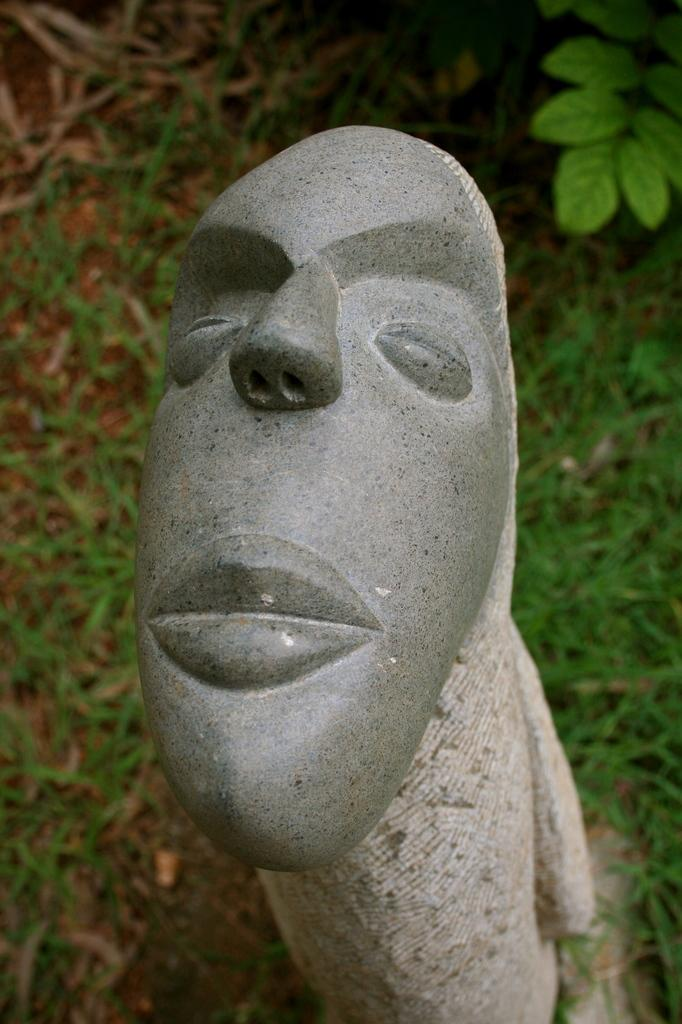What is the main subject of the image? There is a sculpture in the image. What is the ground surface like around the sculpture? There is grass on the ground around the sculpture. Can you describe any other elements in the image? Leaves of a plant are visible in the top right of the image. How does the sculpture guide people in the image? The sculpture does not guide people in the image; it is a static object and does not have the ability to guide. 